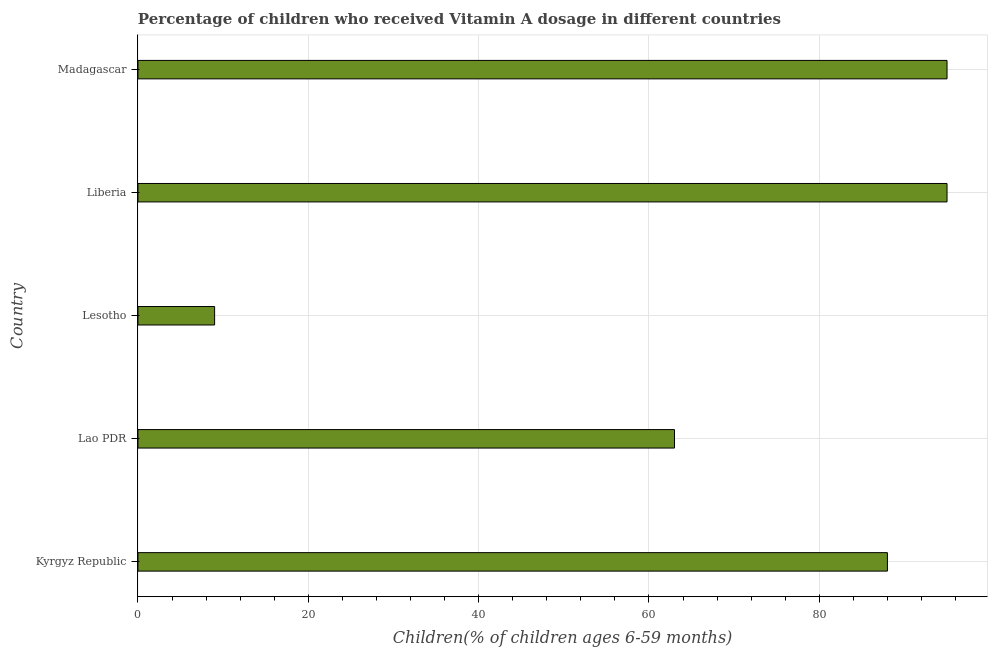Does the graph contain any zero values?
Give a very brief answer. No. Does the graph contain grids?
Keep it short and to the point. Yes. What is the title of the graph?
Your response must be concise. Percentage of children who received Vitamin A dosage in different countries. What is the label or title of the X-axis?
Keep it short and to the point. Children(% of children ages 6-59 months). What is the label or title of the Y-axis?
Give a very brief answer. Country. What is the vitamin a supplementation coverage rate in Liberia?
Make the answer very short. 95. Across all countries, what is the maximum vitamin a supplementation coverage rate?
Your answer should be compact. 95. In which country was the vitamin a supplementation coverage rate maximum?
Provide a short and direct response. Liberia. In which country was the vitamin a supplementation coverage rate minimum?
Give a very brief answer. Lesotho. What is the sum of the vitamin a supplementation coverage rate?
Make the answer very short. 350. What is the difference between the vitamin a supplementation coverage rate in Lesotho and Liberia?
Offer a terse response. -86. In how many countries, is the vitamin a supplementation coverage rate greater than 68 %?
Your response must be concise. 3. What is the ratio of the vitamin a supplementation coverage rate in Kyrgyz Republic to that in Liberia?
Give a very brief answer. 0.93. In how many countries, is the vitamin a supplementation coverage rate greater than the average vitamin a supplementation coverage rate taken over all countries?
Offer a very short reply. 3. How many bars are there?
Your answer should be very brief. 5. Are all the bars in the graph horizontal?
Your answer should be very brief. Yes. What is the difference between two consecutive major ticks on the X-axis?
Offer a terse response. 20. Are the values on the major ticks of X-axis written in scientific E-notation?
Your answer should be very brief. No. What is the Children(% of children ages 6-59 months) of Kyrgyz Republic?
Provide a succinct answer. 88. What is the Children(% of children ages 6-59 months) in Lao PDR?
Provide a short and direct response. 63. What is the Children(% of children ages 6-59 months) in Liberia?
Ensure brevity in your answer.  95. What is the Children(% of children ages 6-59 months) in Madagascar?
Ensure brevity in your answer.  95. What is the difference between the Children(% of children ages 6-59 months) in Kyrgyz Republic and Lao PDR?
Ensure brevity in your answer.  25. What is the difference between the Children(% of children ages 6-59 months) in Kyrgyz Republic and Lesotho?
Make the answer very short. 79. What is the difference between the Children(% of children ages 6-59 months) in Lao PDR and Liberia?
Your response must be concise. -32. What is the difference between the Children(% of children ages 6-59 months) in Lao PDR and Madagascar?
Ensure brevity in your answer.  -32. What is the difference between the Children(% of children ages 6-59 months) in Lesotho and Liberia?
Your answer should be compact. -86. What is the difference between the Children(% of children ages 6-59 months) in Lesotho and Madagascar?
Provide a short and direct response. -86. What is the ratio of the Children(% of children ages 6-59 months) in Kyrgyz Republic to that in Lao PDR?
Keep it short and to the point. 1.4. What is the ratio of the Children(% of children ages 6-59 months) in Kyrgyz Republic to that in Lesotho?
Provide a short and direct response. 9.78. What is the ratio of the Children(% of children ages 6-59 months) in Kyrgyz Republic to that in Liberia?
Your answer should be compact. 0.93. What is the ratio of the Children(% of children ages 6-59 months) in Kyrgyz Republic to that in Madagascar?
Your response must be concise. 0.93. What is the ratio of the Children(% of children ages 6-59 months) in Lao PDR to that in Liberia?
Provide a succinct answer. 0.66. What is the ratio of the Children(% of children ages 6-59 months) in Lao PDR to that in Madagascar?
Your answer should be compact. 0.66. What is the ratio of the Children(% of children ages 6-59 months) in Lesotho to that in Liberia?
Offer a terse response. 0.1. What is the ratio of the Children(% of children ages 6-59 months) in Lesotho to that in Madagascar?
Your answer should be compact. 0.1. 